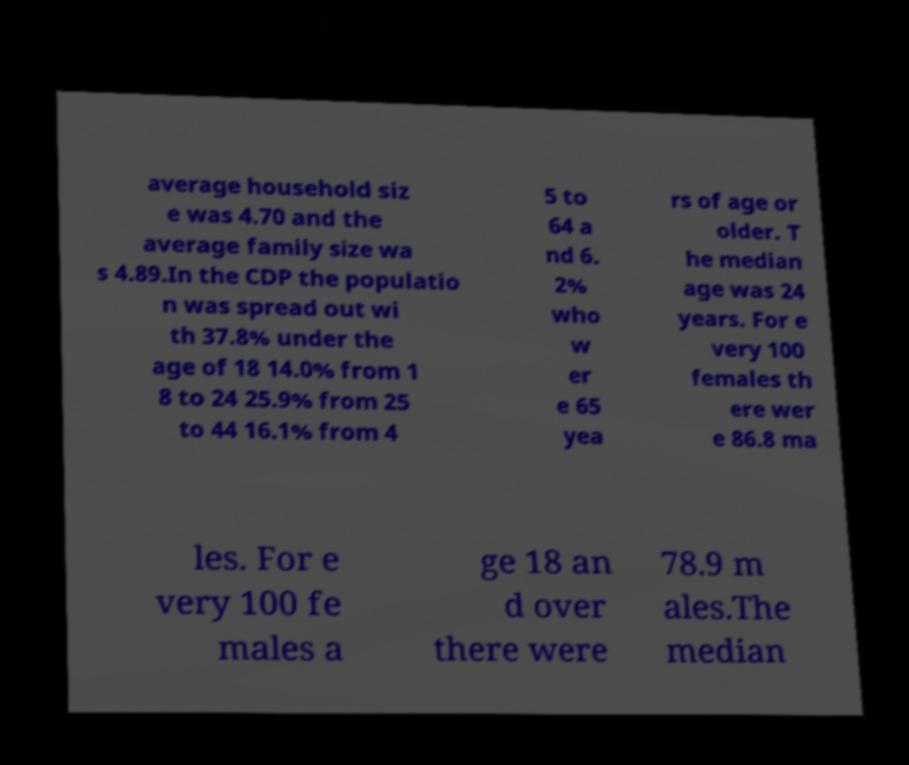For documentation purposes, I need the text within this image transcribed. Could you provide that? average household siz e was 4.70 and the average family size wa s 4.89.In the CDP the populatio n was spread out wi th 37.8% under the age of 18 14.0% from 1 8 to 24 25.9% from 25 to 44 16.1% from 4 5 to 64 a nd 6. 2% who w er e 65 yea rs of age or older. T he median age was 24 years. For e very 100 females th ere wer e 86.8 ma les. For e very 100 fe males a ge 18 an d over there were 78.9 m ales.The median 